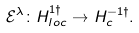<formula> <loc_0><loc_0><loc_500><loc_500>\mathcal { E } ^ { \lambda } \colon H _ { l o c } ^ { 1 \dagger } \rightarrow H _ { c } ^ { - 1 \dagger } .</formula> 